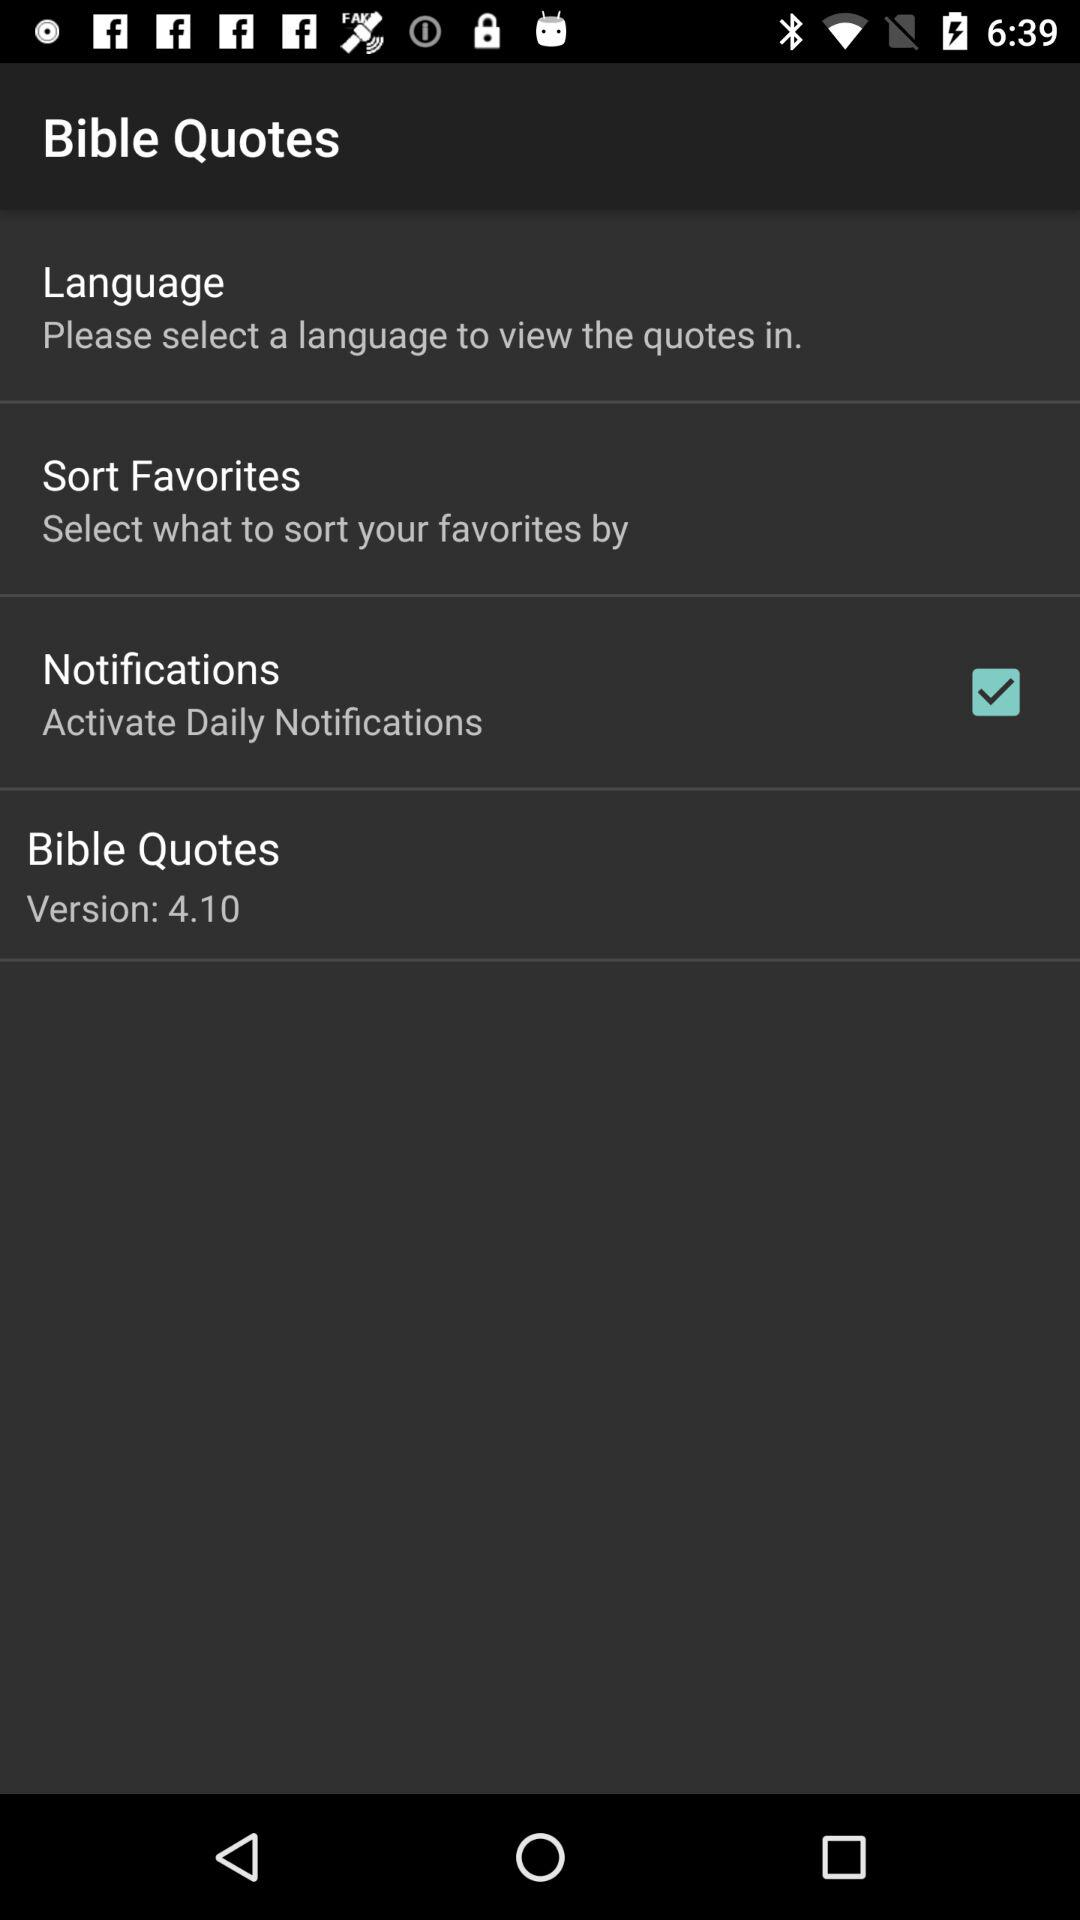What is the version? The version is 4.10. 